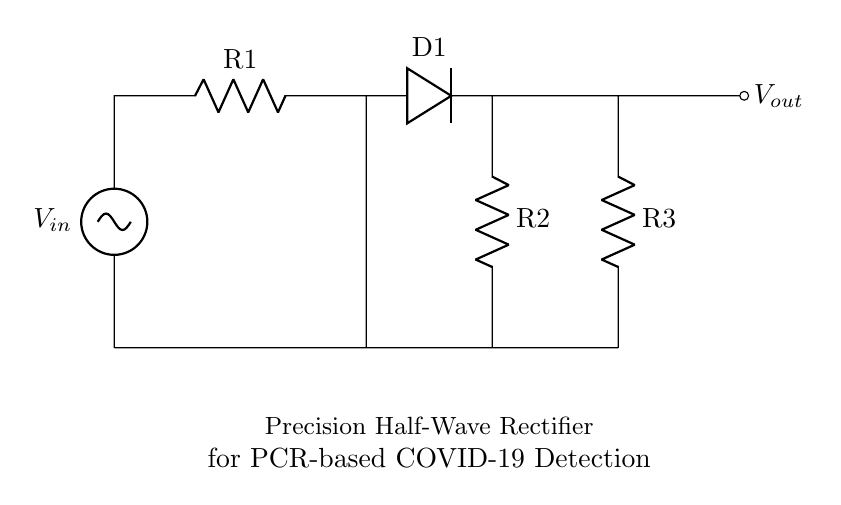What is the input voltage labeled in the circuit? The input voltage in the circuit is denoted as V-in, which is the initial signal fed into the rectifier.
Answer: V-in What type of diodes are used in this circuit? The circuit features a single diode component labeled D1, characteristic of half-wave rectifier circuits, which allows current to flow in one direction only.
Answer: D1 Which component is functioning as the amplifier in this circuit? The operational amplifier, symbolized in the diagram, is utilized to amplify the input signal, emphasizing its role in precision rectification.
Answer: Op amp How many resistors are present in the circuit? There are three resistors labeled R1, R2, and R3, connected at various points in the circuit to manage current and voltage levels effectively.
Answer: Three What does the output voltage represent in the circuit? The output voltage, referred to as V-out, indicates the precision half-wave rectified signal delivered to further processing units after the rectification process.
Answer: V-out How does the precision half-wave rectifier improve signal accuracy? The operational amplifier allows for precision rectification by tightly controlling the output signal, maintaining integrity and reducing error in low-voltage signals, which is crucial for PCR applications.
Answer: Signal accuracy What is the primary purpose of using a half-wave rectifier in PCR machines? The half-wave rectifier converts the alternating current signal into a unidirectional flow, which is essential for processing voltage levels accurately in PCR machines for COVID-19 detection.
Answer: Voltage conversion 